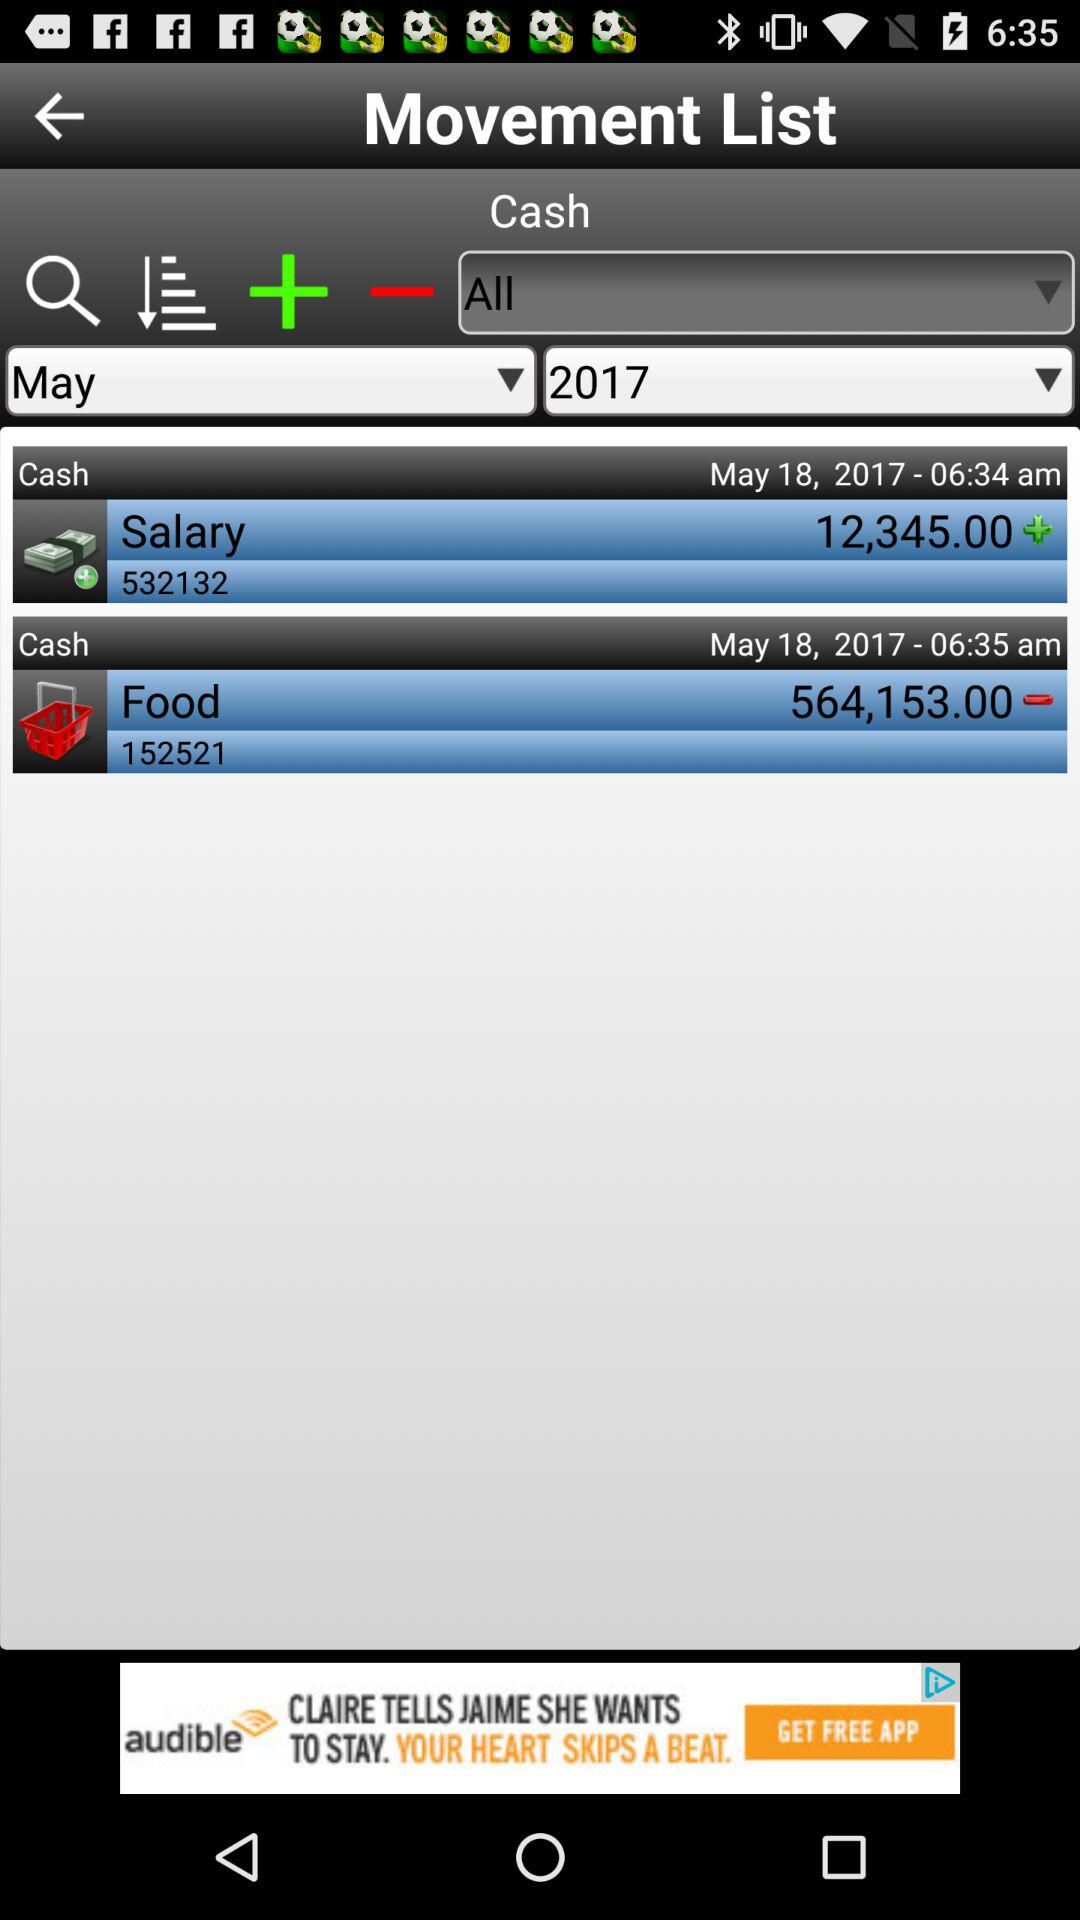What's the transaction number of the salary movement? The transaction number is 532132. 